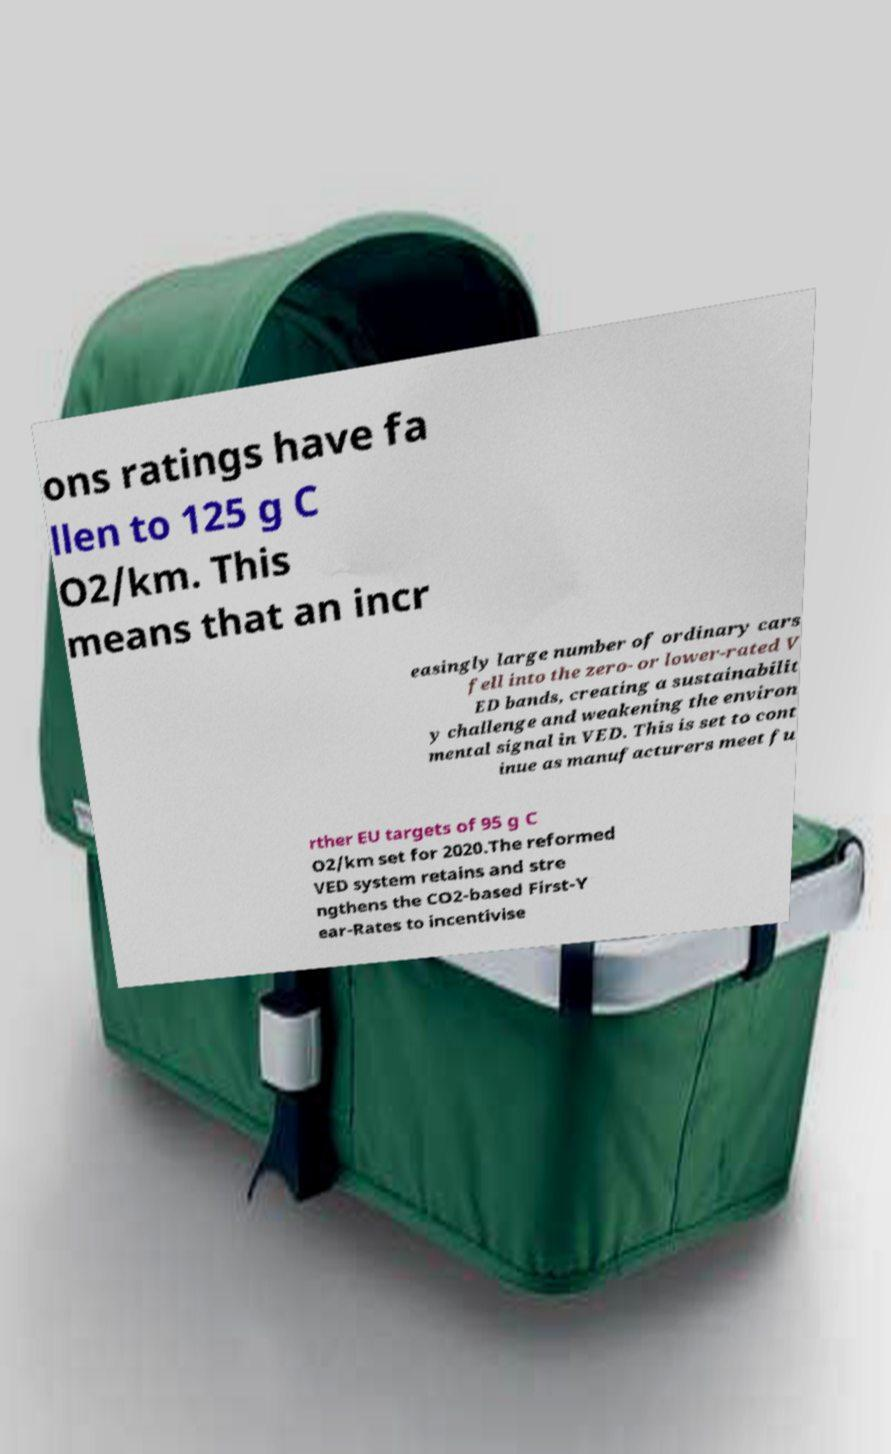Please identify and transcribe the text found in this image. ons ratings have fa llen to 125 g C O2/km. This means that an incr easingly large number of ordinary cars fell into the zero- or lower-rated V ED bands, creating a sustainabilit y challenge and weakening the environ mental signal in VED. This is set to cont inue as manufacturers meet fu rther EU targets of 95 g C O2/km set for 2020.The reformed VED system retains and stre ngthens the CO2-based First-Y ear-Rates to incentivise 